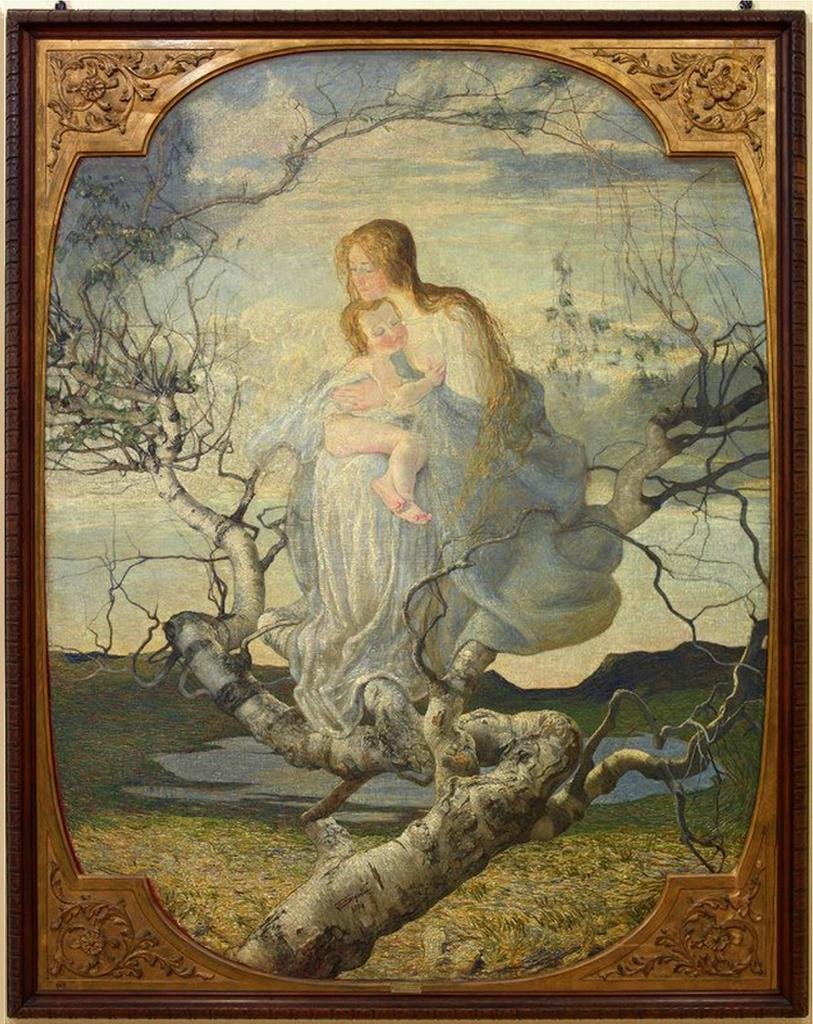What is the main object in the image? There is a frame in the image. What is depicted inside the frame? The frame contains a picture of a lady. What is the lady doing in the picture? The lady is carrying a baby. Where is the lady sitting in the picture? The lady is sitting on a tree stem. How would you describe the weather in the image? The sky is cloudy in the image. How many quarters can be seen in the image? There are no quarters present in the image. Can you describe the polish used on the lady's shoes in the image? There is no information about the lady's shoes or any polish in the image. 